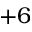<formula> <loc_0><loc_0><loc_500><loc_500>+ 6</formula> 